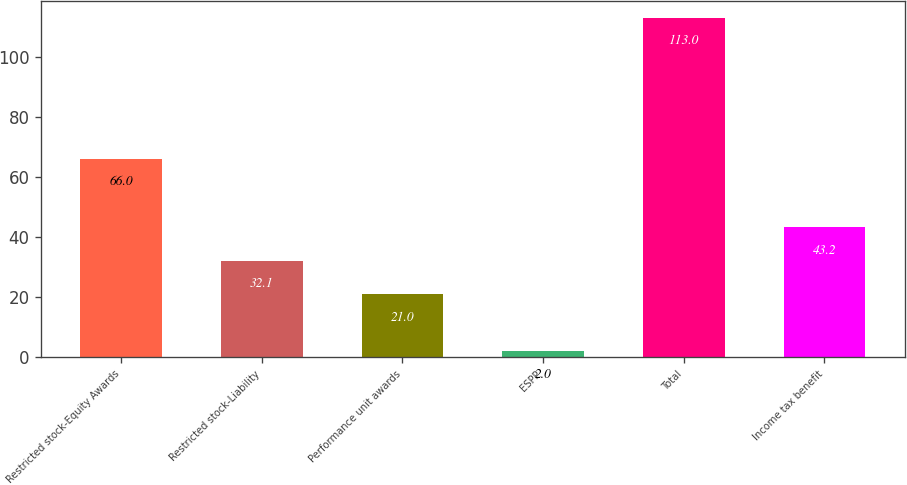Convert chart. <chart><loc_0><loc_0><loc_500><loc_500><bar_chart><fcel>Restricted stock-Equity Awards<fcel>Restricted stock-Liability<fcel>Performance unit awards<fcel>ESPP<fcel>Total<fcel>Income tax benefit<nl><fcel>66<fcel>32.1<fcel>21<fcel>2<fcel>113<fcel>43.2<nl></chart> 